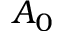<formula> <loc_0><loc_0><loc_500><loc_500>A _ { 0 }</formula> 